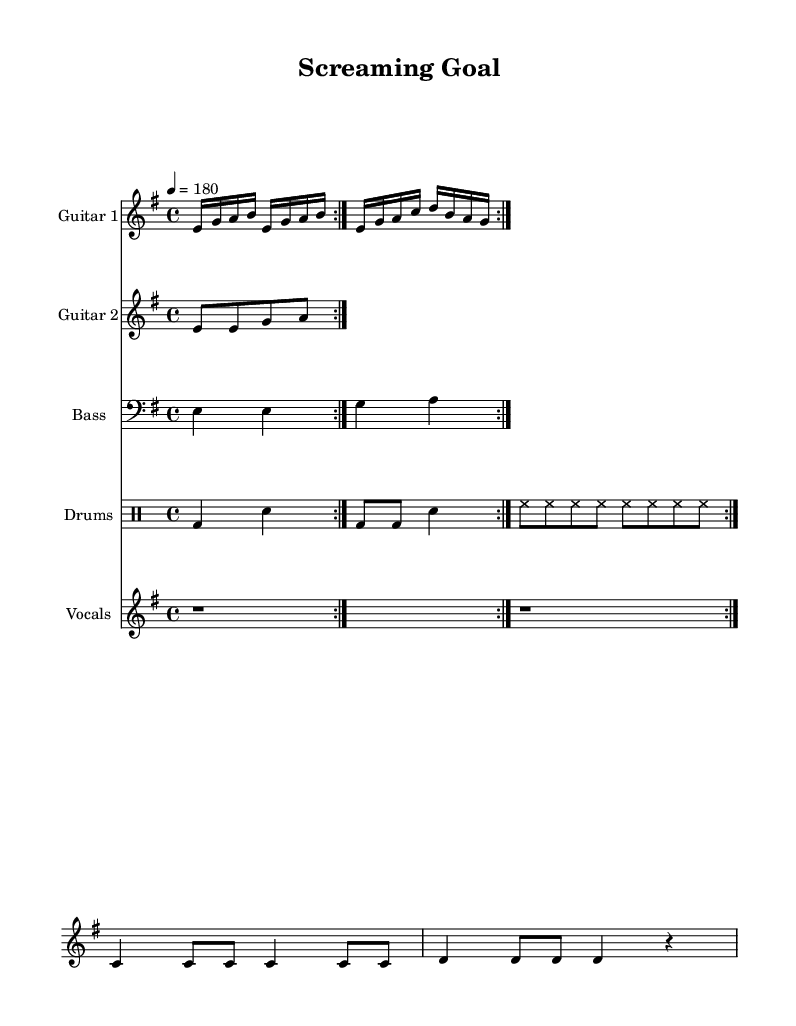What is the key signature of this music? The key signature is E minor, which is indicated by one sharp (F#) on the staff.
Answer: E minor What is the tempo marking in the piece? The tempo is indicated as 4 = 180, meaning there are 180 quarter note beats per minute.
Answer: 180 What is the time signature of the piece? The time signature is 4/4, meaning there are four beats in each measure and a quarter note receives one beat.
Answer: 4/4 How many measures does the guitar part repeat? The guitar part repeats two times, as indicated by the repeat volta markings.
Answer: 2 Which instrument plays the bass part? The bass part is indicated with a staff labeled "Bass" and uses the bass clef.
Answer: Bass What type of meter is used in this song? The song uses a simple quadruple meter, emphasized by the steady four beats per measure in 4/4 time.
Answer: Quadruple What is the lyrical theme of the vocals? The lyrics express the excitement of football commentary, focusing on the passion for Hannover's games.
Answer: Football commentary 